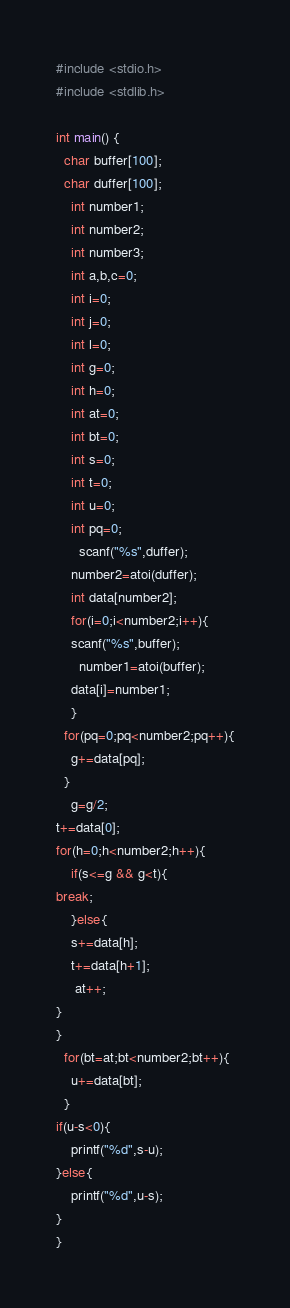<code> <loc_0><loc_0><loc_500><loc_500><_C_>#include <stdio.h>
#include <stdlib.h>

int main() {
  char buffer[100];
  char duffer[100];
    int number1;
    int number2;
    int number3;
    int a,b,c=0;
  	int i=0;
    int j=0;
    int l=0;
    int g=0;
    int h=0;
  	int at=0;
  	int bt=0;
    int s=0;
    int t=0;
  	int u=0;
  	int pq=0;
      scanf("%s",duffer);
    number2=atoi(duffer);
    int data[number2];
    for(i=0;i<number2;i++){
    scanf("%s",buffer);
      number1=atoi(buffer);
    data[i]=number1;
    }
  for(pq=0;pq<number2;pq++){
    g+=data[pq];
  }
	g=g/2;
t+=data[0];
for(h=0;h<number2;h++){
    if(s<=g && g<t){
break;
    }else{
    s+=data[h];
    t+=data[h+1];
     at++;
}
}
  for(bt=at;bt<number2;bt++){
    u+=data[bt];
  }
if(u-s<0){
    printf("%d",s-u);
}else{
    printf("%d",u-s);
}
}
</code> 